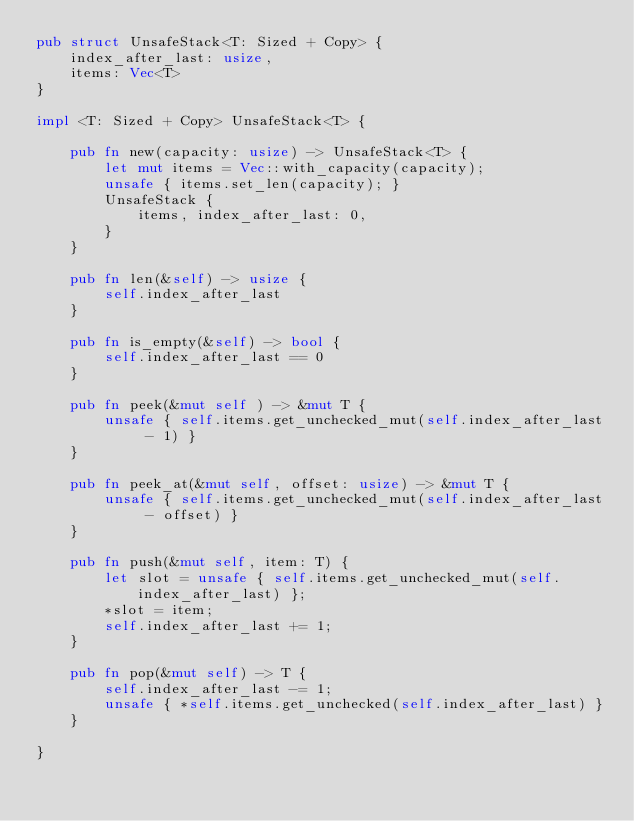<code> <loc_0><loc_0><loc_500><loc_500><_Rust_>pub struct UnsafeStack<T: Sized + Copy> {
    index_after_last: usize,
    items: Vec<T>
}

impl <T: Sized + Copy> UnsafeStack<T> {

    pub fn new(capacity: usize) -> UnsafeStack<T> {
        let mut items = Vec::with_capacity(capacity);
        unsafe { items.set_len(capacity); }
        UnsafeStack {
            items, index_after_last: 0,
        }
    }

    pub fn len(&self) -> usize {
        self.index_after_last
    }

    pub fn is_empty(&self) -> bool {
        self.index_after_last == 0
    }

    pub fn peek(&mut self ) -> &mut T {
        unsafe { self.items.get_unchecked_mut(self.index_after_last - 1) }
    }

    pub fn peek_at(&mut self, offset: usize) -> &mut T {
        unsafe { self.items.get_unchecked_mut(self.index_after_last - offset) }
    }

    pub fn push(&mut self, item: T) {
        let slot = unsafe { self.items.get_unchecked_mut(self.index_after_last) };
        *slot = item;
        self.index_after_last += 1;
    }

    pub fn pop(&mut self) -> T {
        self.index_after_last -= 1;
        unsafe { *self.items.get_unchecked(self.index_after_last) }
    }

}
</code> 